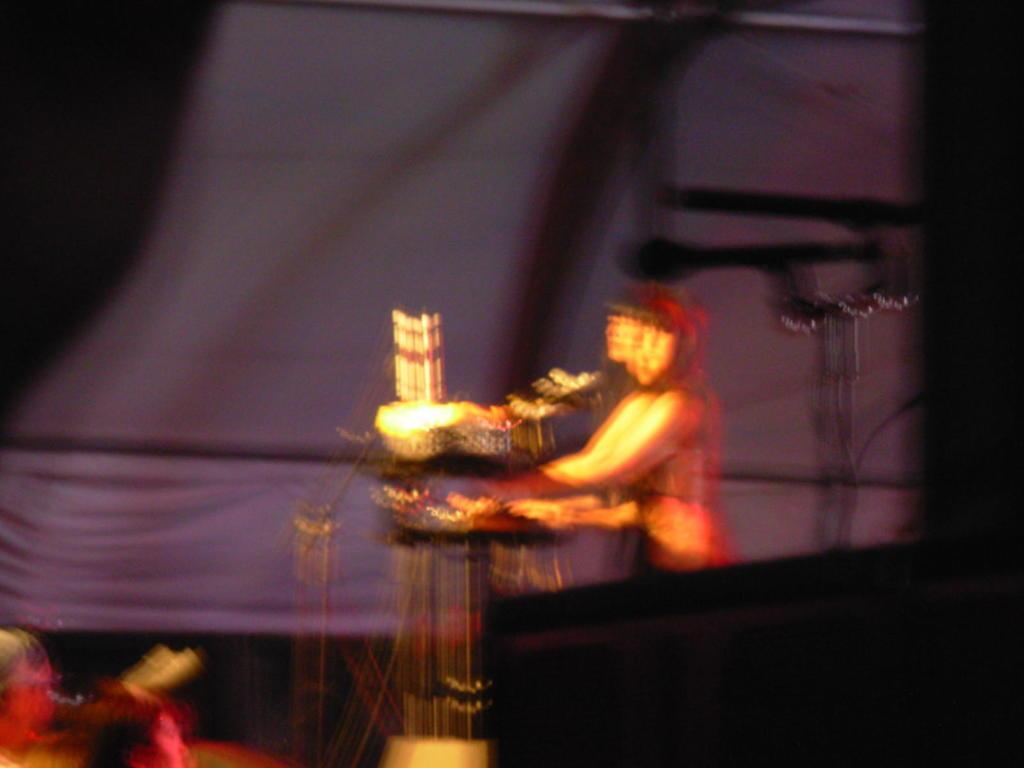Please provide a concise description of this image. In this image we can see a blurred person and musical instruments in front of her. In the background of the image there is a curtain. 